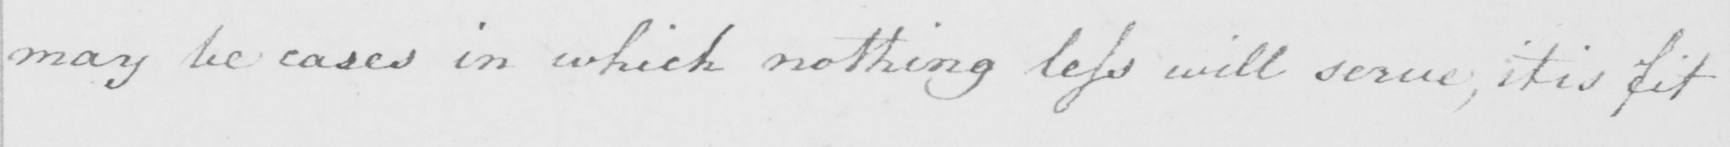Please provide the text content of this handwritten line. may be cases in which nothing less will serve , it is fit 